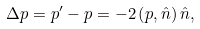Convert formula to latex. <formula><loc_0><loc_0><loc_500><loc_500>\Delta p = p ^ { \prime } - p = - 2 \left ( p , \hat { n } \right ) \hat { n } ,</formula> 